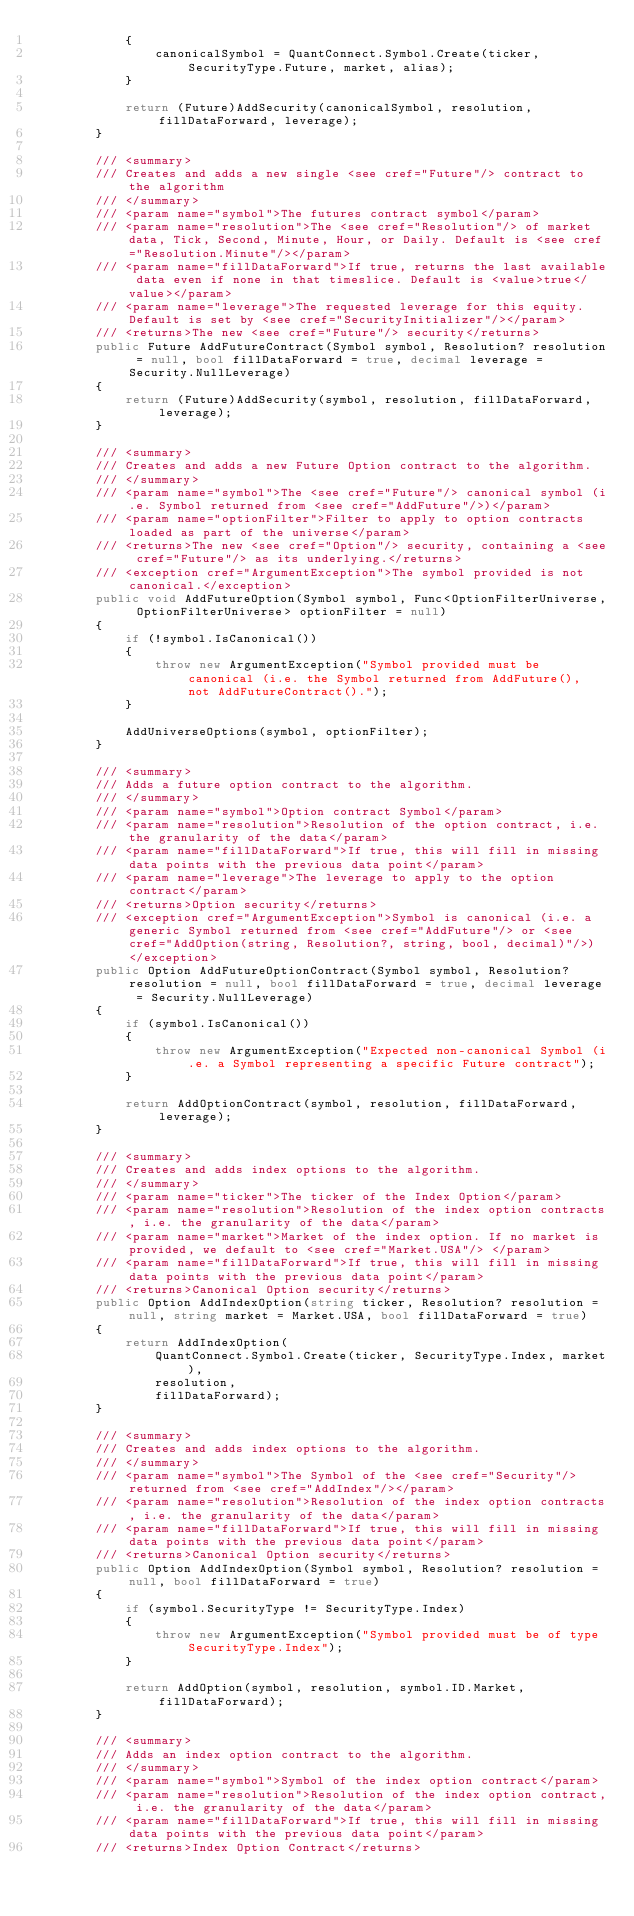Convert code to text. <code><loc_0><loc_0><loc_500><loc_500><_C#_>            {
                canonicalSymbol = QuantConnect.Symbol.Create(ticker, SecurityType.Future, market, alias);
            }

            return (Future)AddSecurity(canonicalSymbol, resolution, fillDataForward, leverage);
        }

        /// <summary>
        /// Creates and adds a new single <see cref="Future"/> contract to the algorithm
        /// </summary>
        /// <param name="symbol">The futures contract symbol</param>
        /// <param name="resolution">The <see cref="Resolution"/> of market data, Tick, Second, Minute, Hour, or Daily. Default is <see cref="Resolution.Minute"/></param>
        /// <param name="fillDataForward">If true, returns the last available data even if none in that timeslice. Default is <value>true</value></param>
        /// <param name="leverage">The requested leverage for this equity. Default is set by <see cref="SecurityInitializer"/></param>
        /// <returns>The new <see cref="Future"/> security</returns>
        public Future AddFutureContract(Symbol symbol, Resolution? resolution = null, bool fillDataForward = true, decimal leverage = Security.NullLeverage)
        {
            return (Future)AddSecurity(symbol, resolution, fillDataForward, leverage);
        }

        /// <summary>
        /// Creates and adds a new Future Option contract to the algorithm.
        /// </summary>
        /// <param name="symbol">The <see cref="Future"/> canonical symbol (i.e. Symbol returned from <see cref="AddFuture"/>)</param>
        /// <param name="optionFilter">Filter to apply to option contracts loaded as part of the universe</param>
        /// <returns>The new <see cref="Option"/> security, containing a <see cref="Future"/> as its underlying.</returns>
        /// <exception cref="ArgumentException">The symbol provided is not canonical.</exception>
        public void AddFutureOption(Symbol symbol, Func<OptionFilterUniverse, OptionFilterUniverse> optionFilter = null)
        {
            if (!symbol.IsCanonical())
            {
                throw new ArgumentException("Symbol provided must be canonical (i.e. the Symbol returned from AddFuture(), not AddFutureContract().");
            }

            AddUniverseOptions(symbol, optionFilter);
        }

        /// <summary>
        /// Adds a future option contract to the algorithm.
        /// </summary>
        /// <param name="symbol">Option contract Symbol</param>
        /// <param name="resolution">Resolution of the option contract, i.e. the granularity of the data</param>
        /// <param name="fillDataForward">If true, this will fill in missing data points with the previous data point</param>
        /// <param name="leverage">The leverage to apply to the option contract</param>
        /// <returns>Option security</returns>
        /// <exception cref="ArgumentException">Symbol is canonical (i.e. a generic Symbol returned from <see cref="AddFuture"/> or <see cref="AddOption(string, Resolution?, string, bool, decimal)"/>)</exception>
        public Option AddFutureOptionContract(Symbol symbol, Resolution? resolution = null, bool fillDataForward = true, decimal leverage = Security.NullLeverage)
        {
            if (symbol.IsCanonical())
            {
                throw new ArgumentException("Expected non-canonical Symbol (i.e. a Symbol representing a specific Future contract");
            }

            return AddOptionContract(symbol, resolution, fillDataForward, leverage);
        }

        /// <summary>
        /// Creates and adds index options to the algorithm.
        /// </summary>
        /// <param name="ticker">The ticker of the Index Option</param>
        /// <param name="resolution">Resolution of the index option contracts, i.e. the granularity of the data</param>
        /// <param name="market">Market of the index option. If no market is provided, we default to <see cref="Market.USA"/> </param>
        /// <param name="fillDataForward">If true, this will fill in missing data points with the previous data point</param>
        /// <returns>Canonical Option security</returns>
        public Option AddIndexOption(string ticker, Resolution? resolution = null, string market = Market.USA, bool fillDataForward = true)
        {
            return AddIndexOption(
                QuantConnect.Symbol.Create(ticker, SecurityType.Index, market),
                resolution,
                fillDataForward);
        }

        /// <summary>
        /// Creates and adds index options to the algorithm.
        /// </summary>
        /// <param name="symbol">The Symbol of the <see cref="Security"/> returned from <see cref="AddIndex"/></param>
        /// <param name="resolution">Resolution of the index option contracts, i.e. the granularity of the data</param>
        /// <param name="fillDataForward">If true, this will fill in missing data points with the previous data point</param>
        /// <returns>Canonical Option security</returns>
        public Option AddIndexOption(Symbol symbol, Resolution? resolution = null, bool fillDataForward = true)
        {
            if (symbol.SecurityType != SecurityType.Index)
            {
                throw new ArgumentException("Symbol provided must be of type SecurityType.Index");
            }

            return AddOption(symbol, resolution, symbol.ID.Market, fillDataForward);
        }

        /// <summary>
        /// Adds an index option contract to the algorithm.
        /// </summary>
        /// <param name="symbol">Symbol of the index option contract</param>
        /// <param name="resolution">Resolution of the index option contract, i.e. the granularity of the data</param>
        /// <param name="fillDataForward">If true, this will fill in missing data points with the previous data point</param>
        /// <returns>Index Option Contract</returns></code> 